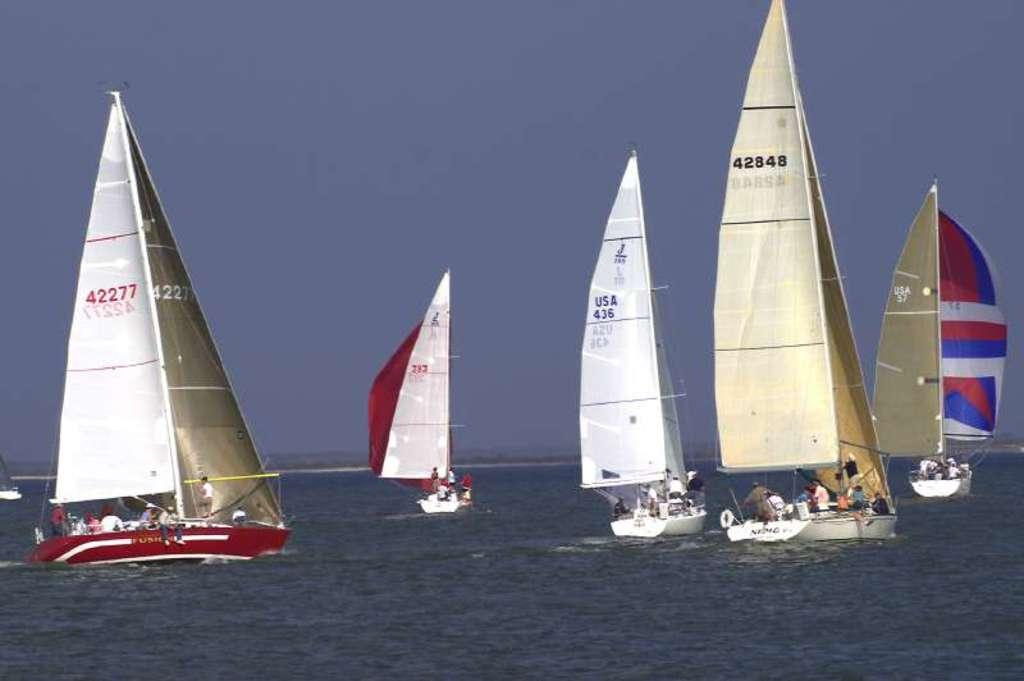What type of vehicles are in the water in the image? There are boats in the water in the image. What are the people in the boats doing? People are sitting and standing in the boats. What is the condition of the sky in the image? The sky is cloudy in the image. What type of needle can be seen in the image? There is no needle present in the image; it features boats in the water with people on them. 